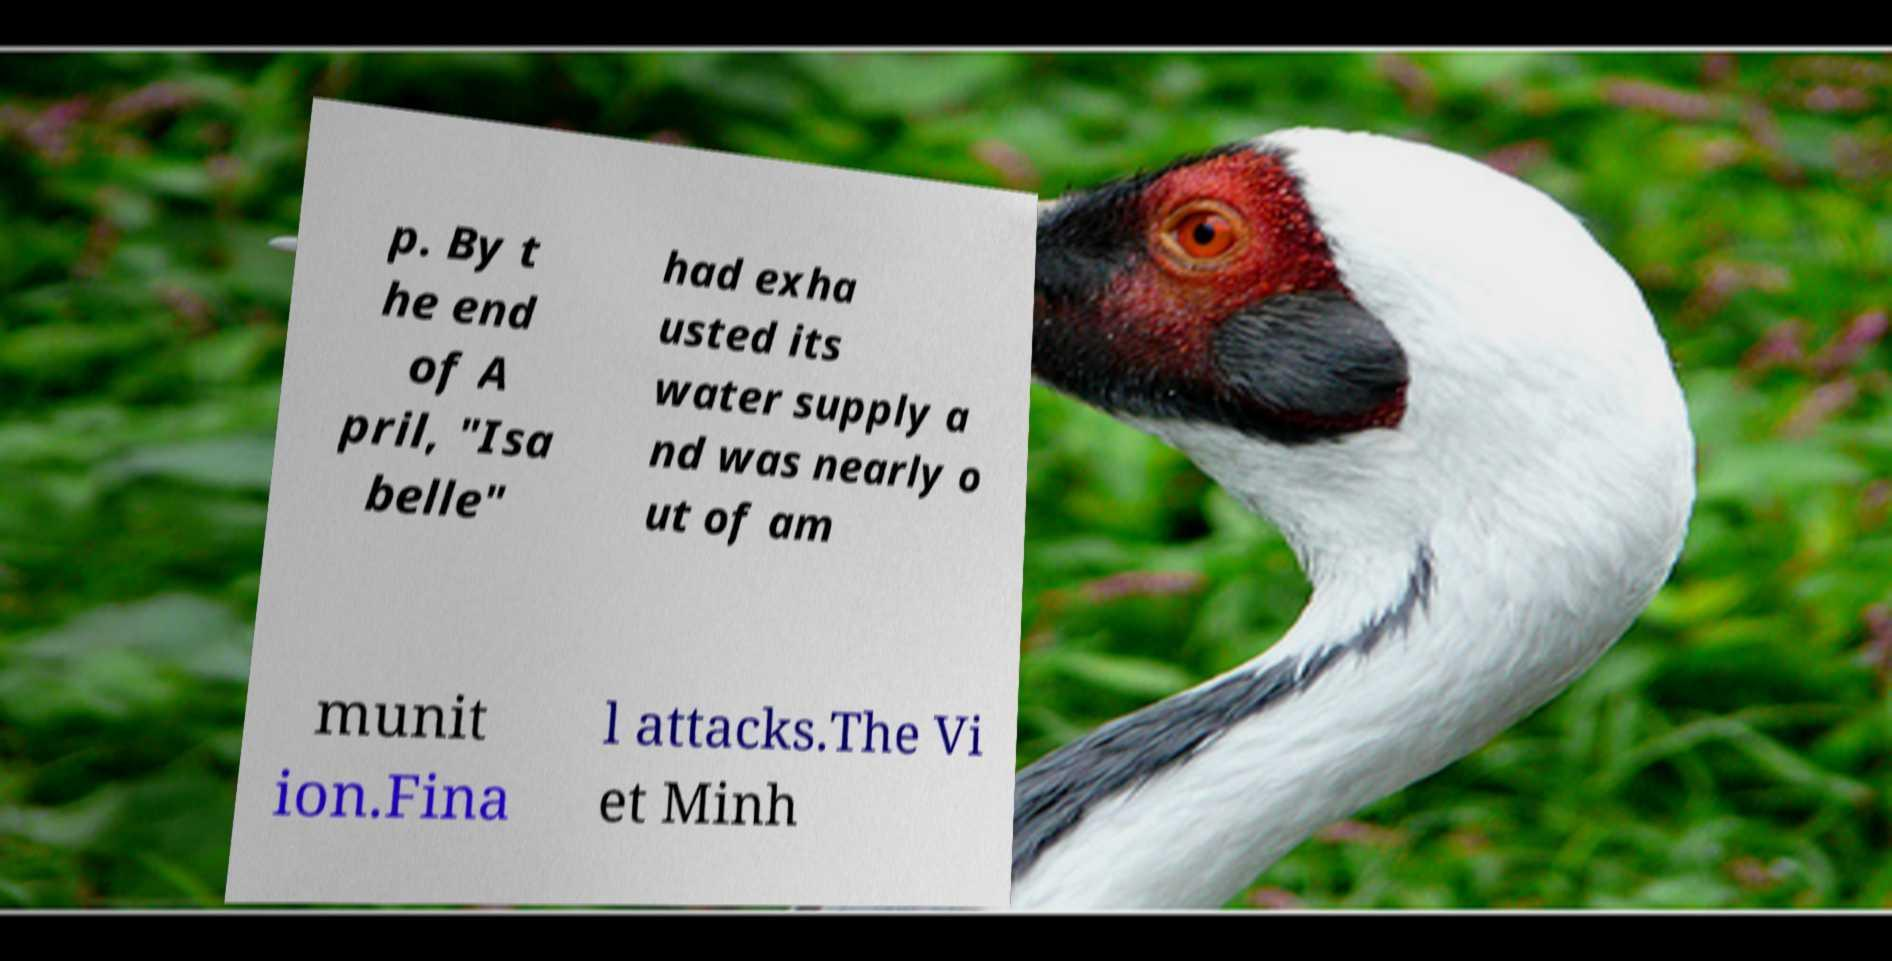What messages or text are displayed in this image? I need them in a readable, typed format. p. By t he end of A pril, "Isa belle" had exha usted its water supply a nd was nearly o ut of am munit ion.Fina l attacks.The Vi et Minh 